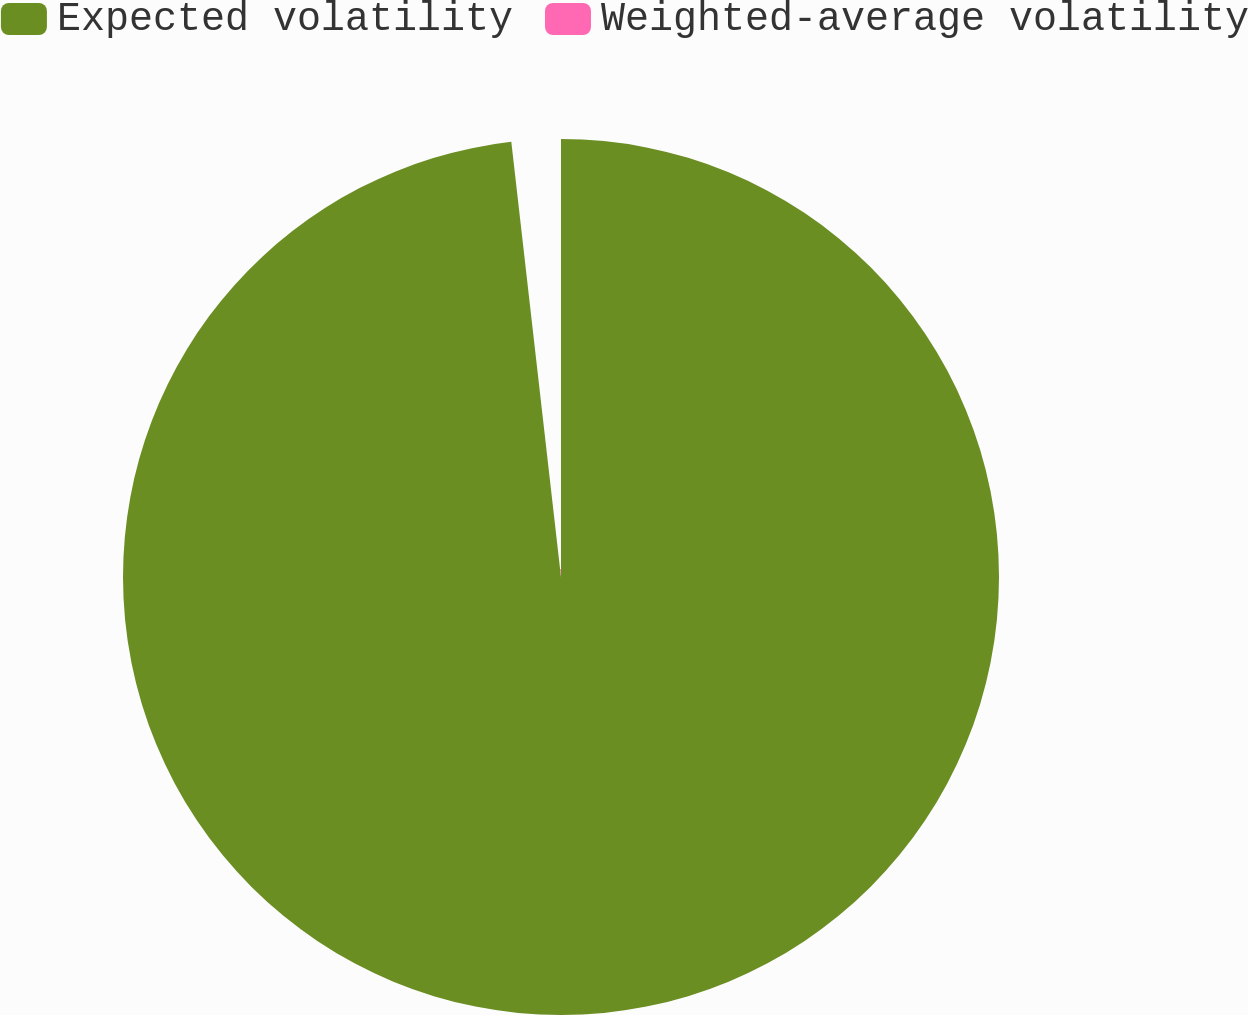Convert chart. <chart><loc_0><loc_0><loc_500><loc_500><pie_chart><fcel>Expected volatility<fcel>Weighted-average volatility<nl><fcel>98.19%<fcel>1.81%<nl></chart> 